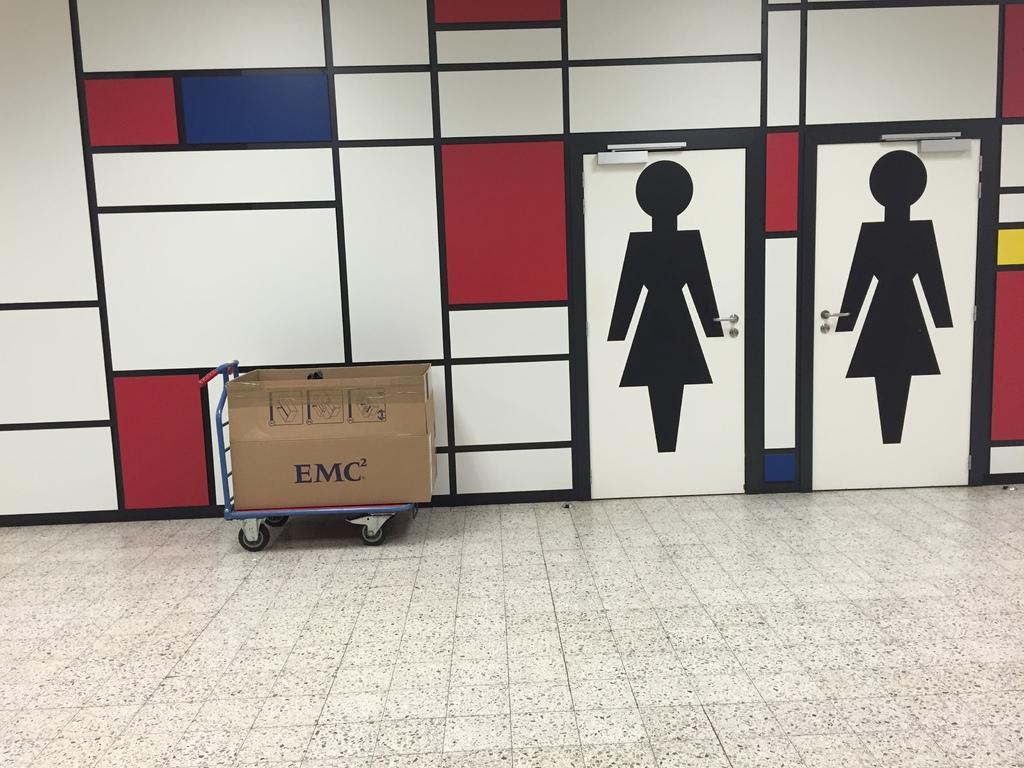How would you summarize this image in a sentence or two? This image is taken indoors. At the bottom of the image there is a floor. In the background there is a wall with paintings and doors. In the middle of the image there is a trolley with a cardboard box on it. 